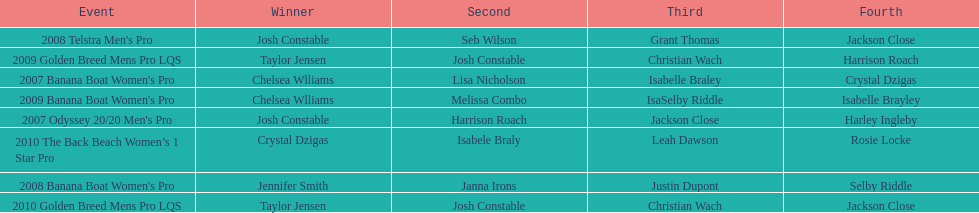Who was the top performer in the 2008 telstra men's pro? Josh Constable. 